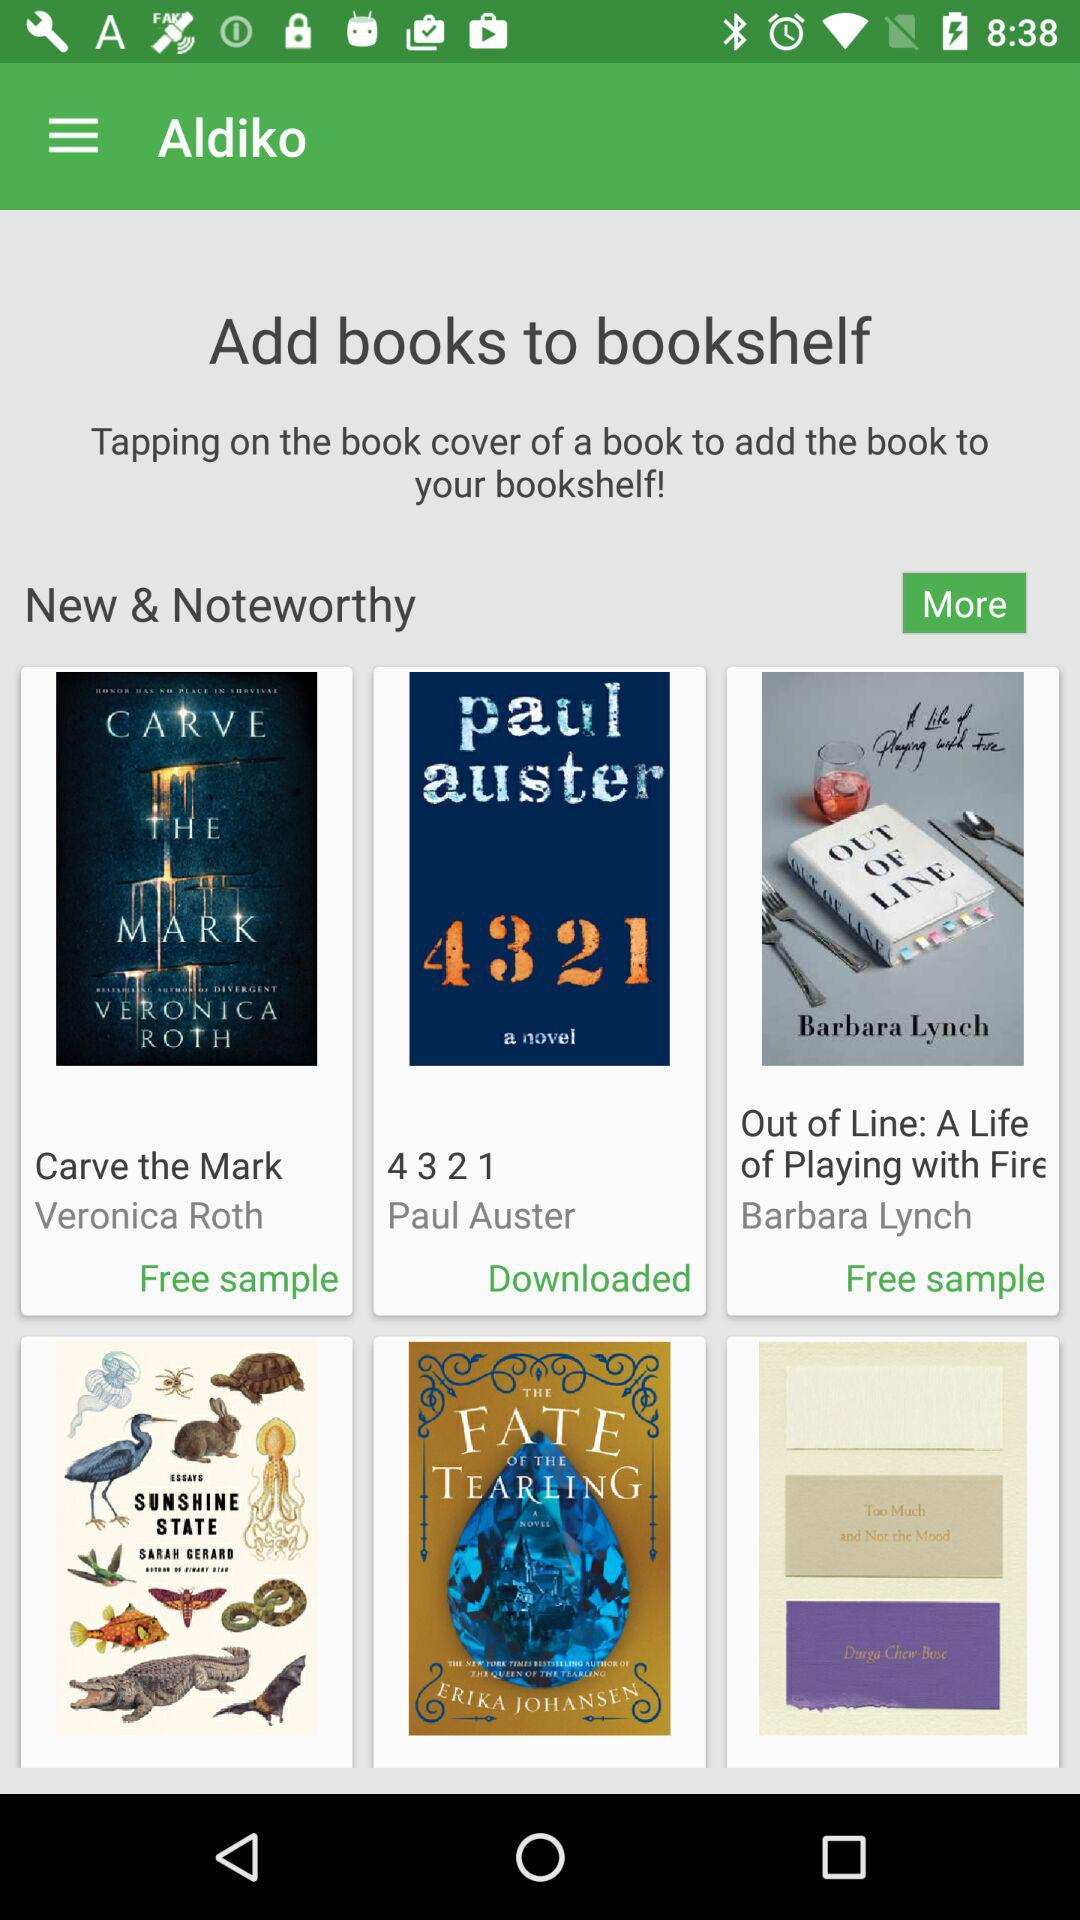How many books have a free sample?
Answer the question using a single word or phrase. 2 